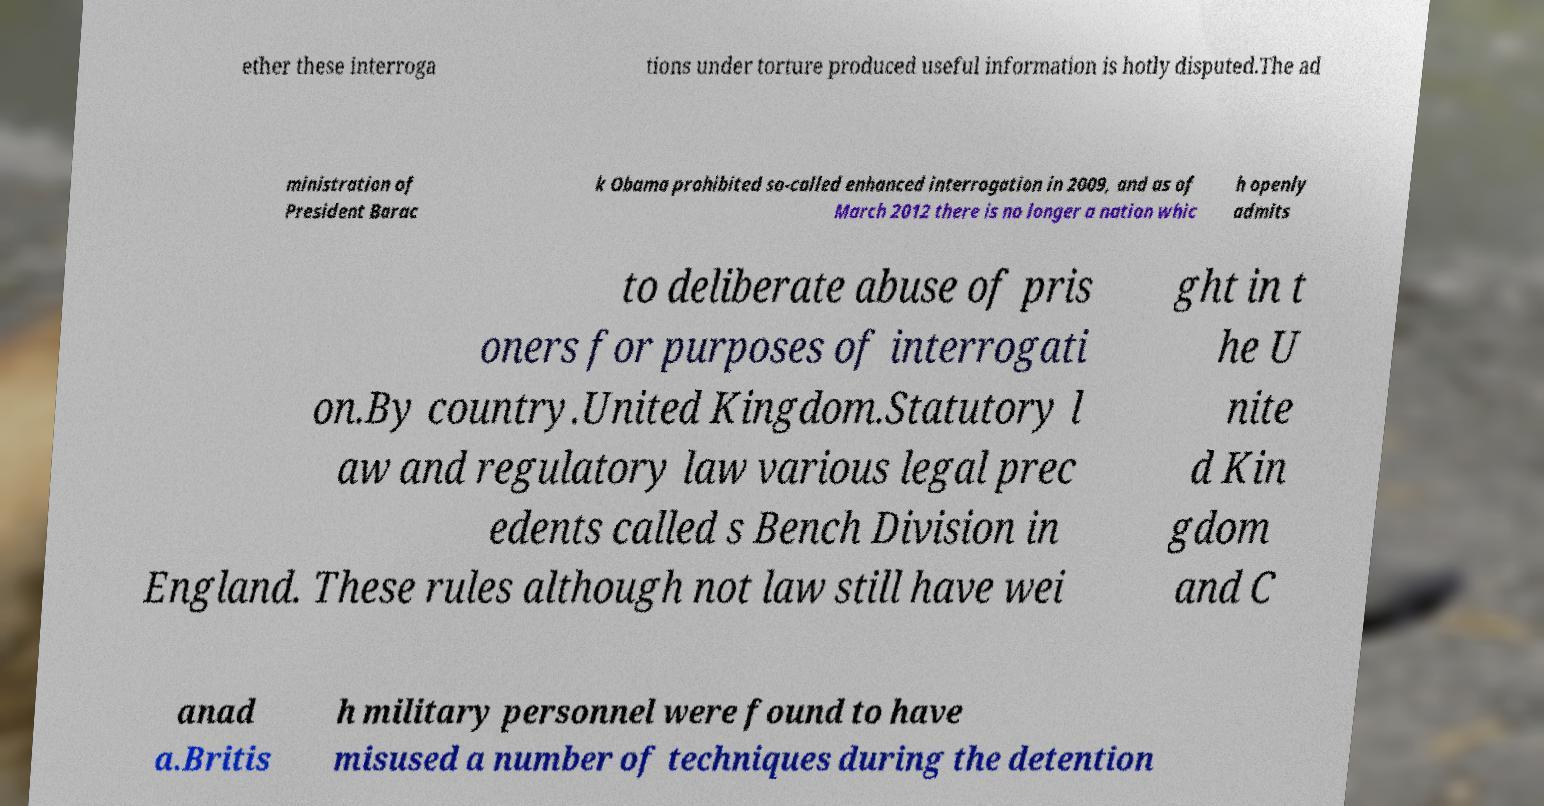For documentation purposes, I need the text within this image transcribed. Could you provide that? ether these interroga tions under torture produced useful information is hotly disputed.The ad ministration of President Barac k Obama prohibited so-called enhanced interrogation in 2009, and as of March 2012 there is no longer a nation whic h openly admits to deliberate abuse of pris oners for purposes of interrogati on.By country.United Kingdom.Statutory l aw and regulatory law various legal prec edents called s Bench Division in England. These rules although not law still have wei ght in t he U nite d Kin gdom and C anad a.Britis h military personnel were found to have misused a number of techniques during the detention 